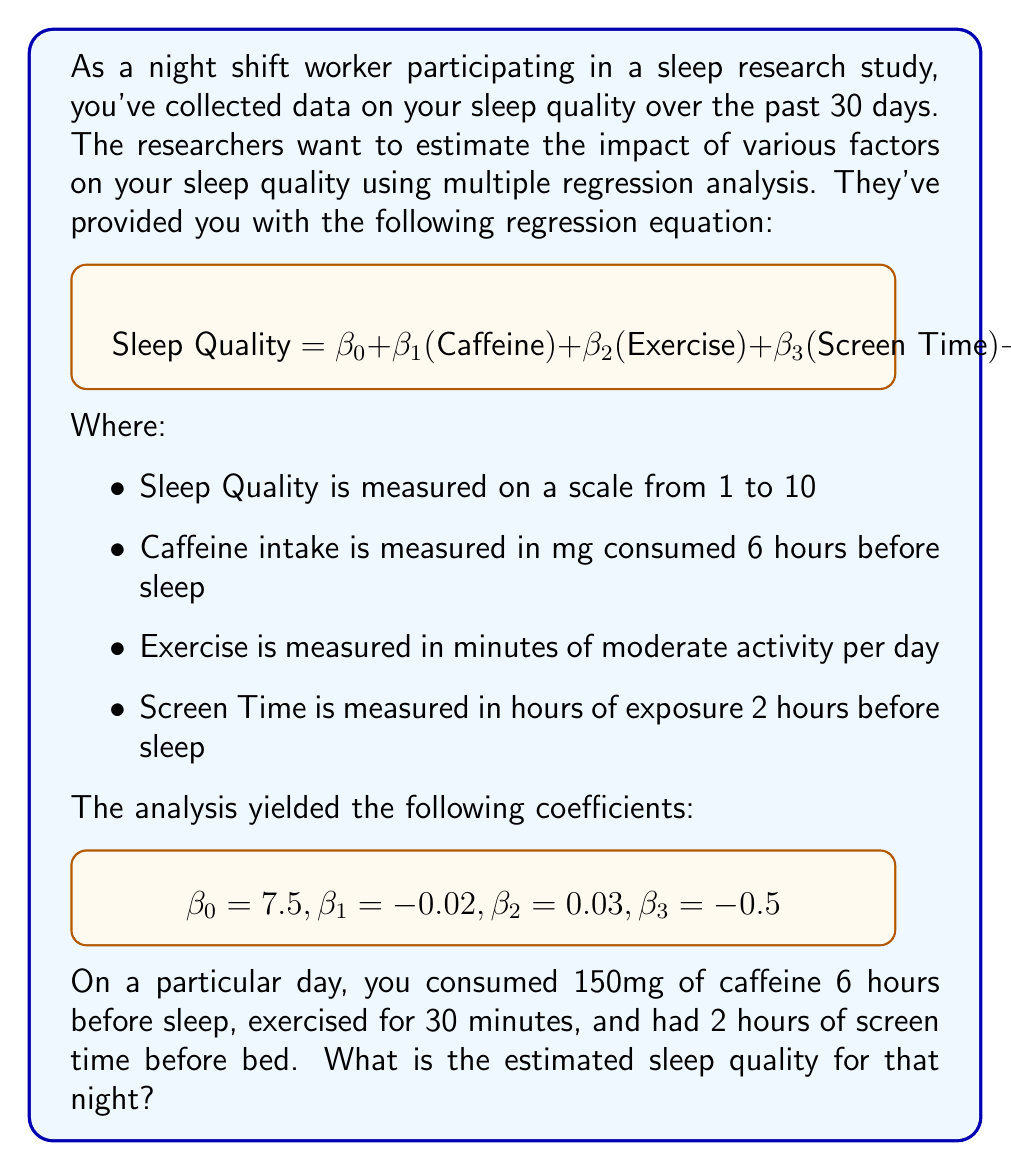What is the answer to this math problem? To solve this problem, we'll use the multiple regression equation provided and plug in the given values. Let's break it down step-by-step:

1. Recall the regression equation:
   $$\text{Sleep Quality} = \beta_0 + \beta_1(\text{Caffeine}) + \beta_2(\text{Exercise}) + \beta_3(\text{Screen Time}) + \varepsilon$$

2. We're given the following coefficient values:
   $$\beta_0 = 7.5, \beta_1 = -0.02, \beta_2 = 0.03, \beta_3 = -0.5$$

3. We're also given the following input values:
   - Caffeine intake: 150mg
   - Exercise: 30 minutes
   - Screen Time: 2 hours

4. Let's substitute these values into the equation:
   $$\text{Sleep Quality} = 7.5 + (-0.02 \times 150) + (0.03 \times 30) + (-0.5 \times 2) + \varepsilon$$

5. Now, let's calculate each term:
   - $\beta_0 = 7.5$
   - $\beta_1(\text{Caffeine}) = -0.02 \times 150 = -3$
   - $\beta_2(\text{Exercise}) = 0.03 \times 30 = 0.9$
   - $\beta_3(\text{Screen Time}) = -0.5 \times 2 = -1$

6. Add up all the terms:
   $$\text{Sleep Quality} = 7.5 + (-3) + 0.9 + (-1) + \varepsilon$$
   $$\text{Sleep Quality} = 4.4 + \varepsilon$$

7. In practical applications, we typically ignore the error term $\varepsilon$ when making predictions. Therefore, our estimated sleep quality is 4.4.
Answer: 4.4 